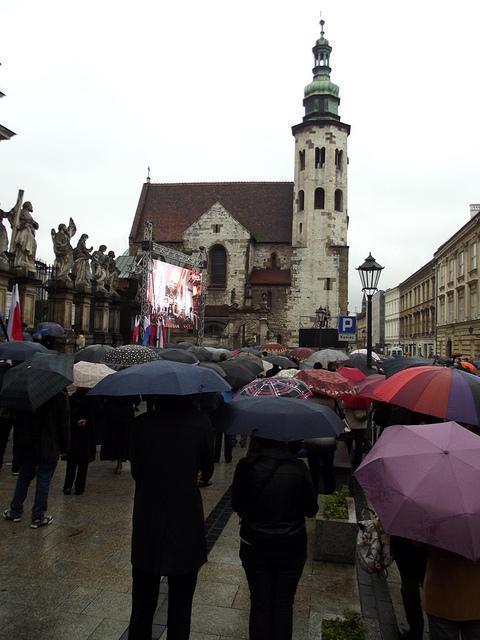Why are the people holding umbrellas?
Choose the correct response, then elucidate: 'Answer: answer
Rationale: rationale.'
Options: To buy, it's raining, to dance, it's snowing. Answer: it's raining.
Rationale: The ground is wet and the people don't want to get wet. 